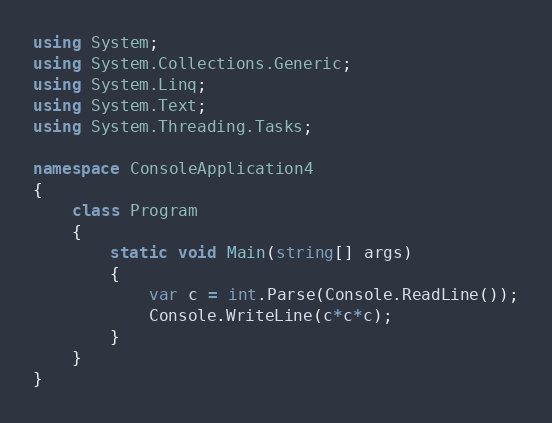<code> <loc_0><loc_0><loc_500><loc_500><_C#_>using System;
using System.Collections.Generic;
using System.Linq;
using System.Text;
using System.Threading.Tasks;

namespace ConsoleApplication4
{
    class Program
    {
        static void Main(string[] args)
        {
            var c = int.Parse(Console.ReadLine());
            Console.WriteLine(c*c*c);
        }
    }
}</code> 